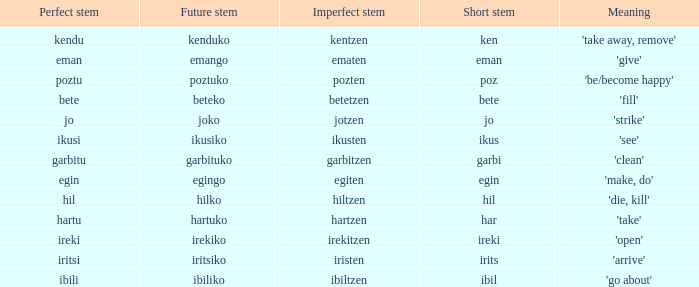Name the perfect stem for jo 1.0. 